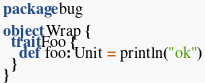<code> <loc_0><loc_0><loc_500><loc_500><_Scala_>
package bug
 
object Wrap {
  trait Foo {
    def foo: Unit = println("ok")
  }
}
</code> 